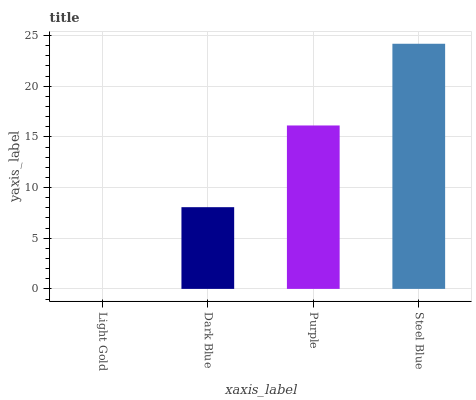Is Light Gold the minimum?
Answer yes or no. Yes. Is Steel Blue the maximum?
Answer yes or no. Yes. Is Dark Blue the minimum?
Answer yes or no. No. Is Dark Blue the maximum?
Answer yes or no. No. Is Dark Blue greater than Light Gold?
Answer yes or no. Yes. Is Light Gold less than Dark Blue?
Answer yes or no. Yes. Is Light Gold greater than Dark Blue?
Answer yes or no. No. Is Dark Blue less than Light Gold?
Answer yes or no. No. Is Purple the high median?
Answer yes or no. Yes. Is Dark Blue the low median?
Answer yes or no. Yes. Is Light Gold the high median?
Answer yes or no. No. Is Purple the low median?
Answer yes or no. No. 